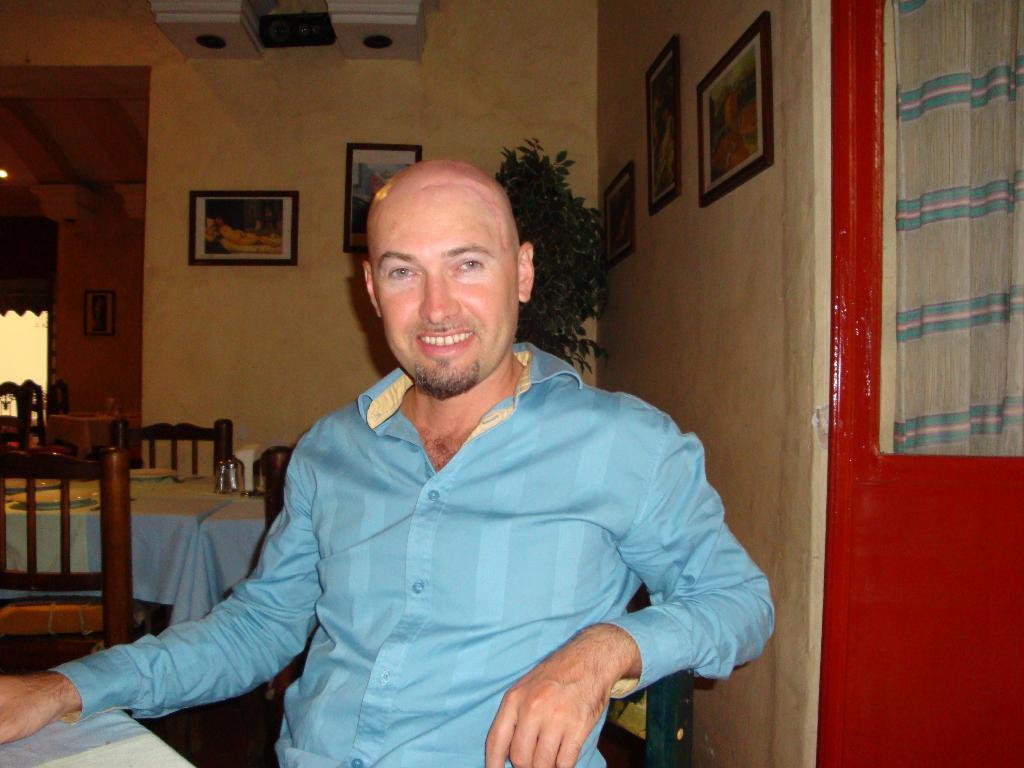Could you give a brief overview of what you see in this image? In this picture we can see a man wore blue color shirt sitting on chair and smiling and beside to him there is table and on table we can see glasses, plates, spoons and in background we can see wall with frames, tree, some more chairs. 